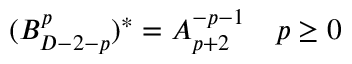<formula> <loc_0><loc_0><loc_500><loc_500>( B _ { D - 2 - p } ^ { p } ) ^ { * } = A _ { p + 2 } ^ { - p - 1 } \quad p \geq 0</formula> 